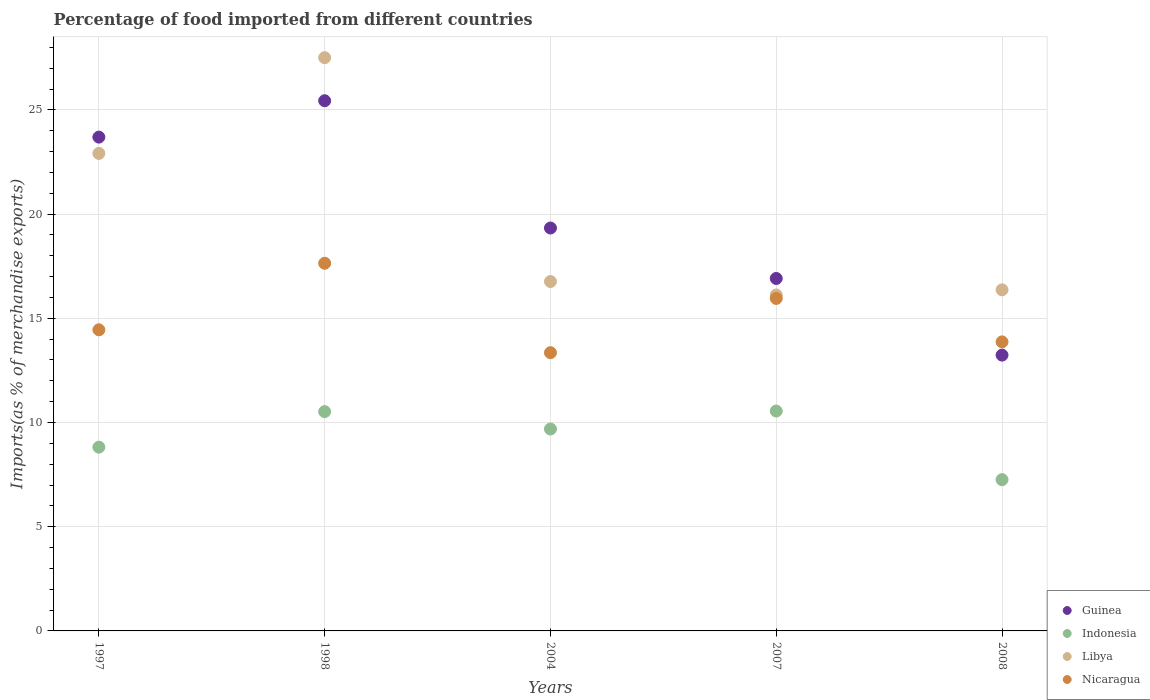How many different coloured dotlines are there?
Provide a succinct answer. 4. What is the percentage of imports to different countries in Libya in 2008?
Keep it short and to the point. 16.37. Across all years, what is the maximum percentage of imports to different countries in Indonesia?
Keep it short and to the point. 10.55. Across all years, what is the minimum percentage of imports to different countries in Guinea?
Give a very brief answer. 13.23. In which year was the percentage of imports to different countries in Guinea maximum?
Your response must be concise. 1998. What is the total percentage of imports to different countries in Libya in the graph?
Offer a terse response. 99.67. What is the difference between the percentage of imports to different countries in Nicaragua in 1997 and that in 2008?
Give a very brief answer. 0.58. What is the difference between the percentage of imports to different countries in Nicaragua in 1997 and the percentage of imports to different countries in Guinea in 2007?
Your answer should be very brief. -2.46. What is the average percentage of imports to different countries in Nicaragua per year?
Offer a terse response. 15.05. In the year 1997, what is the difference between the percentage of imports to different countries in Libya and percentage of imports to different countries in Indonesia?
Offer a terse response. 14.09. In how many years, is the percentage of imports to different countries in Indonesia greater than 22 %?
Keep it short and to the point. 0. What is the ratio of the percentage of imports to different countries in Guinea in 1997 to that in 2007?
Offer a terse response. 1.4. What is the difference between the highest and the second highest percentage of imports to different countries in Indonesia?
Offer a terse response. 0.03. What is the difference between the highest and the lowest percentage of imports to different countries in Guinea?
Offer a very short reply. 12.2. Is it the case that in every year, the sum of the percentage of imports to different countries in Nicaragua and percentage of imports to different countries in Libya  is greater than the percentage of imports to different countries in Guinea?
Ensure brevity in your answer.  Yes. Does the percentage of imports to different countries in Indonesia monotonically increase over the years?
Ensure brevity in your answer.  No. How many dotlines are there?
Keep it short and to the point. 4. How many years are there in the graph?
Provide a succinct answer. 5. What is the difference between two consecutive major ticks on the Y-axis?
Keep it short and to the point. 5. Does the graph contain any zero values?
Offer a very short reply. No. Does the graph contain grids?
Ensure brevity in your answer.  Yes. How many legend labels are there?
Your response must be concise. 4. How are the legend labels stacked?
Your answer should be compact. Vertical. What is the title of the graph?
Offer a terse response. Percentage of food imported from different countries. What is the label or title of the Y-axis?
Make the answer very short. Imports(as % of merchandise exports). What is the Imports(as % of merchandise exports) of Guinea in 1997?
Provide a succinct answer. 23.69. What is the Imports(as % of merchandise exports) of Indonesia in 1997?
Offer a terse response. 8.82. What is the Imports(as % of merchandise exports) in Libya in 1997?
Ensure brevity in your answer.  22.91. What is the Imports(as % of merchandise exports) of Nicaragua in 1997?
Provide a short and direct response. 14.45. What is the Imports(as % of merchandise exports) of Guinea in 1998?
Offer a terse response. 25.44. What is the Imports(as % of merchandise exports) in Indonesia in 1998?
Make the answer very short. 10.52. What is the Imports(as % of merchandise exports) of Libya in 1998?
Your answer should be very brief. 27.5. What is the Imports(as % of merchandise exports) in Nicaragua in 1998?
Make the answer very short. 17.64. What is the Imports(as % of merchandise exports) in Guinea in 2004?
Provide a succinct answer. 19.33. What is the Imports(as % of merchandise exports) in Indonesia in 2004?
Provide a succinct answer. 9.69. What is the Imports(as % of merchandise exports) of Libya in 2004?
Ensure brevity in your answer.  16.76. What is the Imports(as % of merchandise exports) of Nicaragua in 2004?
Offer a terse response. 13.35. What is the Imports(as % of merchandise exports) in Guinea in 2007?
Ensure brevity in your answer.  16.91. What is the Imports(as % of merchandise exports) of Indonesia in 2007?
Provide a succinct answer. 10.55. What is the Imports(as % of merchandise exports) in Libya in 2007?
Make the answer very short. 16.12. What is the Imports(as % of merchandise exports) of Nicaragua in 2007?
Your answer should be very brief. 15.95. What is the Imports(as % of merchandise exports) of Guinea in 2008?
Your answer should be compact. 13.23. What is the Imports(as % of merchandise exports) in Indonesia in 2008?
Keep it short and to the point. 7.26. What is the Imports(as % of merchandise exports) of Libya in 2008?
Give a very brief answer. 16.37. What is the Imports(as % of merchandise exports) in Nicaragua in 2008?
Provide a short and direct response. 13.87. Across all years, what is the maximum Imports(as % of merchandise exports) of Guinea?
Make the answer very short. 25.44. Across all years, what is the maximum Imports(as % of merchandise exports) in Indonesia?
Ensure brevity in your answer.  10.55. Across all years, what is the maximum Imports(as % of merchandise exports) of Libya?
Your response must be concise. 27.5. Across all years, what is the maximum Imports(as % of merchandise exports) of Nicaragua?
Give a very brief answer. 17.64. Across all years, what is the minimum Imports(as % of merchandise exports) in Guinea?
Offer a terse response. 13.23. Across all years, what is the minimum Imports(as % of merchandise exports) of Indonesia?
Your response must be concise. 7.26. Across all years, what is the minimum Imports(as % of merchandise exports) in Libya?
Make the answer very short. 16.12. Across all years, what is the minimum Imports(as % of merchandise exports) in Nicaragua?
Offer a terse response. 13.35. What is the total Imports(as % of merchandise exports) in Guinea in the graph?
Ensure brevity in your answer.  98.61. What is the total Imports(as % of merchandise exports) in Indonesia in the graph?
Offer a very short reply. 46.83. What is the total Imports(as % of merchandise exports) in Libya in the graph?
Provide a short and direct response. 99.67. What is the total Imports(as % of merchandise exports) in Nicaragua in the graph?
Provide a succinct answer. 75.26. What is the difference between the Imports(as % of merchandise exports) of Guinea in 1997 and that in 1998?
Offer a very short reply. -1.75. What is the difference between the Imports(as % of merchandise exports) of Indonesia in 1997 and that in 1998?
Offer a very short reply. -1.71. What is the difference between the Imports(as % of merchandise exports) of Libya in 1997 and that in 1998?
Give a very brief answer. -4.59. What is the difference between the Imports(as % of merchandise exports) of Nicaragua in 1997 and that in 1998?
Your answer should be compact. -3.19. What is the difference between the Imports(as % of merchandise exports) of Guinea in 1997 and that in 2004?
Your answer should be compact. 4.36. What is the difference between the Imports(as % of merchandise exports) of Indonesia in 1997 and that in 2004?
Offer a terse response. -0.87. What is the difference between the Imports(as % of merchandise exports) in Libya in 1997 and that in 2004?
Make the answer very short. 6.15. What is the difference between the Imports(as % of merchandise exports) of Nicaragua in 1997 and that in 2004?
Make the answer very short. 1.1. What is the difference between the Imports(as % of merchandise exports) of Guinea in 1997 and that in 2007?
Your answer should be very brief. 6.78. What is the difference between the Imports(as % of merchandise exports) in Indonesia in 1997 and that in 2007?
Provide a short and direct response. -1.73. What is the difference between the Imports(as % of merchandise exports) in Libya in 1997 and that in 2007?
Make the answer very short. 6.79. What is the difference between the Imports(as % of merchandise exports) in Nicaragua in 1997 and that in 2007?
Keep it short and to the point. -1.51. What is the difference between the Imports(as % of merchandise exports) in Guinea in 1997 and that in 2008?
Your answer should be very brief. 10.46. What is the difference between the Imports(as % of merchandise exports) of Indonesia in 1997 and that in 2008?
Offer a terse response. 1.56. What is the difference between the Imports(as % of merchandise exports) of Libya in 1997 and that in 2008?
Your answer should be very brief. 6.55. What is the difference between the Imports(as % of merchandise exports) of Nicaragua in 1997 and that in 2008?
Provide a short and direct response. 0.58. What is the difference between the Imports(as % of merchandise exports) of Guinea in 1998 and that in 2004?
Provide a succinct answer. 6.11. What is the difference between the Imports(as % of merchandise exports) of Indonesia in 1998 and that in 2004?
Your answer should be compact. 0.83. What is the difference between the Imports(as % of merchandise exports) of Libya in 1998 and that in 2004?
Offer a terse response. 10.74. What is the difference between the Imports(as % of merchandise exports) of Nicaragua in 1998 and that in 2004?
Offer a terse response. 4.29. What is the difference between the Imports(as % of merchandise exports) in Guinea in 1998 and that in 2007?
Your answer should be compact. 8.53. What is the difference between the Imports(as % of merchandise exports) of Indonesia in 1998 and that in 2007?
Provide a short and direct response. -0.03. What is the difference between the Imports(as % of merchandise exports) in Libya in 1998 and that in 2007?
Keep it short and to the point. 11.39. What is the difference between the Imports(as % of merchandise exports) in Nicaragua in 1998 and that in 2007?
Provide a succinct answer. 1.69. What is the difference between the Imports(as % of merchandise exports) in Guinea in 1998 and that in 2008?
Your answer should be compact. 12.2. What is the difference between the Imports(as % of merchandise exports) of Indonesia in 1998 and that in 2008?
Keep it short and to the point. 3.26. What is the difference between the Imports(as % of merchandise exports) in Libya in 1998 and that in 2008?
Offer a very short reply. 11.14. What is the difference between the Imports(as % of merchandise exports) in Nicaragua in 1998 and that in 2008?
Give a very brief answer. 3.77. What is the difference between the Imports(as % of merchandise exports) of Guinea in 2004 and that in 2007?
Give a very brief answer. 2.42. What is the difference between the Imports(as % of merchandise exports) of Indonesia in 2004 and that in 2007?
Give a very brief answer. -0.86. What is the difference between the Imports(as % of merchandise exports) in Libya in 2004 and that in 2007?
Make the answer very short. 0.65. What is the difference between the Imports(as % of merchandise exports) of Nicaragua in 2004 and that in 2007?
Offer a terse response. -2.6. What is the difference between the Imports(as % of merchandise exports) of Guinea in 2004 and that in 2008?
Your answer should be compact. 6.1. What is the difference between the Imports(as % of merchandise exports) of Indonesia in 2004 and that in 2008?
Keep it short and to the point. 2.43. What is the difference between the Imports(as % of merchandise exports) in Libya in 2004 and that in 2008?
Make the answer very short. 0.4. What is the difference between the Imports(as % of merchandise exports) of Nicaragua in 2004 and that in 2008?
Provide a succinct answer. -0.52. What is the difference between the Imports(as % of merchandise exports) in Guinea in 2007 and that in 2008?
Your answer should be very brief. 3.68. What is the difference between the Imports(as % of merchandise exports) of Indonesia in 2007 and that in 2008?
Keep it short and to the point. 3.29. What is the difference between the Imports(as % of merchandise exports) in Libya in 2007 and that in 2008?
Your response must be concise. -0.25. What is the difference between the Imports(as % of merchandise exports) of Nicaragua in 2007 and that in 2008?
Give a very brief answer. 2.09. What is the difference between the Imports(as % of merchandise exports) in Guinea in 1997 and the Imports(as % of merchandise exports) in Indonesia in 1998?
Give a very brief answer. 13.17. What is the difference between the Imports(as % of merchandise exports) in Guinea in 1997 and the Imports(as % of merchandise exports) in Libya in 1998?
Give a very brief answer. -3.81. What is the difference between the Imports(as % of merchandise exports) in Guinea in 1997 and the Imports(as % of merchandise exports) in Nicaragua in 1998?
Provide a succinct answer. 6.05. What is the difference between the Imports(as % of merchandise exports) of Indonesia in 1997 and the Imports(as % of merchandise exports) of Libya in 1998?
Offer a terse response. -18.69. What is the difference between the Imports(as % of merchandise exports) of Indonesia in 1997 and the Imports(as % of merchandise exports) of Nicaragua in 1998?
Provide a succinct answer. -8.82. What is the difference between the Imports(as % of merchandise exports) of Libya in 1997 and the Imports(as % of merchandise exports) of Nicaragua in 1998?
Provide a short and direct response. 5.27. What is the difference between the Imports(as % of merchandise exports) in Guinea in 1997 and the Imports(as % of merchandise exports) in Indonesia in 2004?
Your answer should be very brief. 14.01. What is the difference between the Imports(as % of merchandise exports) of Guinea in 1997 and the Imports(as % of merchandise exports) of Libya in 2004?
Provide a succinct answer. 6.93. What is the difference between the Imports(as % of merchandise exports) in Guinea in 1997 and the Imports(as % of merchandise exports) in Nicaragua in 2004?
Provide a short and direct response. 10.34. What is the difference between the Imports(as % of merchandise exports) in Indonesia in 1997 and the Imports(as % of merchandise exports) in Libya in 2004?
Your answer should be very brief. -7.95. What is the difference between the Imports(as % of merchandise exports) of Indonesia in 1997 and the Imports(as % of merchandise exports) of Nicaragua in 2004?
Your answer should be very brief. -4.53. What is the difference between the Imports(as % of merchandise exports) of Libya in 1997 and the Imports(as % of merchandise exports) of Nicaragua in 2004?
Make the answer very short. 9.56. What is the difference between the Imports(as % of merchandise exports) in Guinea in 1997 and the Imports(as % of merchandise exports) in Indonesia in 2007?
Keep it short and to the point. 13.14. What is the difference between the Imports(as % of merchandise exports) of Guinea in 1997 and the Imports(as % of merchandise exports) of Libya in 2007?
Your response must be concise. 7.57. What is the difference between the Imports(as % of merchandise exports) of Guinea in 1997 and the Imports(as % of merchandise exports) of Nicaragua in 2007?
Provide a succinct answer. 7.74. What is the difference between the Imports(as % of merchandise exports) in Indonesia in 1997 and the Imports(as % of merchandise exports) in Libya in 2007?
Keep it short and to the point. -7.3. What is the difference between the Imports(as % of merchandise exports) in Indonesia in 1997 and the Imports(as % of merchandise exports) in Nicaragua in 2007?
Make the answer very short. -7.14. What is the difference between the Imports(as % of merchandise exports) in Libya in 1997 and the Imports(as % of merchandise exports) in Nicaragua in 2007?
Offer a terse response. 6.96. What is the difference between the Imports(as % of merchandise exports) of Guinea in 1997 and the Imports(as % of merchandise exports) of Indonesia in 2008?
Your answer should be compact. 16.44. What is the difference between the Imports(as % of merchandise exports) in Guinea in 1997 and the Imports(as % of merchandise exports) in Libya in 2008?
Your answer should be compact. 7.33. What is the difference between the Imports(as % of merchandise exports) of Guinea in 1997 and the Imports(as % of merchandise exports) of Nicaragua in 2008?
Offer a very short reply. 9.82. What is the difference between the Imports(as % of merchandise exports) in Indonesia in 1997 and the Imports(as % of merchandise exports) in Libya in 2008?
Make the answer very short. -7.55. What is the difference between the Imports(as % of merchandise exports) in Indonesia in 1997 and the Imports(as % of merchandise exports) in Nicaragua in 2008?
Keep it short and to the point. -5.05. What is the difference between the Imports(as % of merchandise exports) in Libya in 1997 and the Imports(as % of merchandise exports) in Nicaragua in 2008?
Make the answer very short. 9.04. What is the difference between the Imports(as % of merchandise exports) in Guinea in 1998 and the Imports(as % of merchandise exports) in Indonesia in 2004?
Your answer should be compact. 15.75. What is the difference between the Imports(as % of merchandise exports) in Guinea in 1998 and the Imports(as % of merchandise exports) in Libya in 2004?
Your answer should be compact. 8.67. What is the difference between the Imports(as % of merchandise exports) in Guinea in 1998 and the Imports(as % of merchandise exports) in Nicaragua in 2004?
Make the answer very short. 12.09. What is the difference between the Imports(as % of merchandise exports) in Indonesia in 1998 and the Imports(as % of merchandise exports) in Libya in 2004?
Offer a very short reply. -6.24. What is the difference between the Imports(as % of merchandise exports) in Indonesia in 1998 and the Imports(as % of merchandise exports) in Nicaragua in 2004?
Provide a succinct answer. -2.83. What is the difference between the Imports(as % of merchandise exports) of Libya in 1998 and the Imports(as % of merchandise exports) of Nicaragua in 2004?
Your answer should be very brief. 14.15. What is the difference between the Imports(as % of merchandise exports) of Guinea in 1998 and the Imports(as % of merchandise exports) of Indonesia in 2007?
Your response must be concise. 14.89. What is the difference between the Imports(as % of merchandise exports) in Guinea in 1998 and the Imports(as % of merchandise exports) in Libya in 2007?
Keep it short and to the point. 9.32. What is the difference between the Imports(as % of merchandise exports) of Guinea in 1998 and the Imports(as % of merchandise exports) of Nicaragua in 2007?
Offer a very short reply. 9.48. What is the difference between the Imports(as % of merchandise exports) in Indonesia in 1998 and the Imports(as % of merchandise exports) in Libya in 2007?
Ensure brevity in your answer.  -5.6. What is the difference between the Imports(as % of merchandise exports) in Indonesia in 1998 and the Imports(as % of merchandise exports) in Nicaragua in 2007?
Give a very brief answer. -5.43. What is the difference between the Imports(as % of merchandise exports) in Libya in 1998 and the Imports(as % of merchandise exports) in Nicaragua in 2007?
Keep it short and to the point. 11.55. What is the difference between the Imports(as % of merchandise exports) of Guinea in 1998 and the Imports(as % of merchandise exports) of Indonesia in 2008?
Keep it short and to the point. 18.18. What is the difference between the Imports(as % of merchandise exports) in Guinea in 1998 and the Imports(as % of merchandise exports) in Libya in 2008?
Keep it short and to the point. 9.07. What is the difference between the Imports(as % of merchandise exports) in Guinea in 1998 and the Imports(as % of merchandise exports) in Nicaragua in 2008?
Your answer should be compact. 11.57. What is the difference between the Imports(as % of merchandise exports) of Indonesia in 1998 and the Imports(as % of merchandise exports) of Libya in 2008?
Provide a short and direct response. -5.84. What is the difference between the Imports(as % of merchandise exports) in Indonesia in 1998 and the Imports(as % of merchandise exports) in Nicaragua in 2008?
Make the answer very short. -3.35. What is the difference between the Imports(as % of merchandise exports) in Libya in 1998 and the Imports(as % of merchandise exports) in Nicaragua in 2008?
Ensure brevity in your answer.  13.64. What is the difference between the Imports(as % of merchandise exports) in Guinea in 2004 and the Imports(as % of merchandise exports) in Indonesia in 2007?
Ensure brevity in your answer.  8.78. What is the difference between the Imports(as % of merchandise exports) of Guinea in 2004 and the Imports(as % of merchandise exports) of Libya in 2007?
Ensure brevity in your answer.  3.21. What is the difference between the Imports(as % of merchandise exports) in Guinea in 2004 and the Imports(as % of merchandise exports) in Nicaragua in 2007?
Your answer should be compact. 3.38. What is the difference between the Imports(as % of merchandise exports) of Indonesia in 2004 and the Imports(as % of merchandise exports) of Libya in 2007?
Your response must be concise. -6.43. What is the difference between the Imports(as % of merchandise exports) in Indonesia in 2004 and the Imports(as % of merchandise exports) in Nicaragua in 2007?
Offer a terse response. -6.27. What is the difference between the Imports(as % of merchandise exports) in Libya in 2004 and the Imports(as % of merchandise exports) in Nicaragua in 2007?
Provide a short and direct response. 0.81. What is the difference between the Imports(as % of merchandise exports) in Guinea in 2004 and the Imports(as % of merchandise exports) in Indonesia in 2008?
Provide a succinct answer. 12.07. What is the difference between the Imports(as % of merchandise exports) in Guinea in 2004 and the Imports(as % of merchandise exports) in Libya in 2008?
Your response must be concise. 2.97. What is the difference between the Imports(as % of merchandise exports) of Guinea in 2004 and the Imports(as % of merchandise exports) of Nicaragua in 2008?
Your response must be concise. 5.46. What is the difference between the Imports(as % of merchandise exports) of Indonesia in 2004 and the Imports(as % of merchandise exports) of Libya in 2008?
Make the answer very short. -6.68. What is the difference between the Imports(as % of merchandise exports) of Indonesia in 2004 and the Imports(as % of merchandise exports) of Nicaragua in 2008?
Your answer should be very brief. -4.18. What is the difference between the Imports(as % of merchandise exports) in Libya in 2004 and the Imports(as % of merchandise exports) in Nicaragua in 2008?
Your response must be concise. 2.9. What is the difference between the Imports(as % of merchandise exports) of Guinea in 2007 and the Imports(as % of merchandise exports) of Indonesia in 2008?
Ensure brevity in your answer.  9.65. What is the difference between the Imports(as % of merchandise exports) in Guinea in 2007 and the Imports(as % of merchandise exports) in Libya in 2008?
Your response must be concise. 0.55. What is the difference between the Imports(as % of merchandise exports) in Guinea in 2007 and the Imports(as % of merchandise exports) in Nicaragua in 2008?
Offer a very short reply. 3.04. What is the difference between the Imports(as % of merchandise exports) of Indonesia in 2007 and the Imports(as % of merchandise exports) of Libya in 2008?
Your answer should be compact. -5.82. What is the difference between the Imports(as % of merchandise exports) of Indonesia in 2007 and the Imports(as % of merchandise exports) of Nicaragua in 2008?
Ensure brevity in your answer.  -3.32. What is the difference between the Imports(as % of merchandise exports) in Libya in 2007 and the Imports(as % of merchandise exports) in Nicaragua in 2008?
Your answer should be compact. 2.25. What is the average Imports(as % of merchandise exports) of Guinea per year?
Provide a succinct answer. 19.72. What is the average Imports(as % of merchandise exports) in Indonesia per year?
Make the answer very short. 9.37. What is the average Imports(as % of merchandise exports) of Libya per year?
Give a very brief answer. 19.93. What is the average Imports(as % of merchandise exports) in Nicaragua per year?
Ensure brevity in your answer.  15.05. In the year 1997, what is the difference between the Imports(as % of merchandise exports) in Guinea and Imports(as % of merchandise exports) in Indonesia?
Give a very brief answer. 14.88. In the year 1997, what is the difference between the Imports(as % of merchandise exports) in Guinea and Imports(as % of merchandise exports) in Libya?
Ensure brevity in your answer.  0.78. In the year 1997, what is the difference between the Imports(as % of merchandise exports) in Guinea and Imports(as % of merchandise exports) in Nicaragua?
Your answer should be compact. 9.25. In the year 1997, what is the difference between the Imports(as % of merchandise exports) of Indonesia and Imports(as % of merchandise exports) of Libya?
Provide a short and direct response. -14.09. In the year 1997, what is the difference between the Imports(as % of merchandise exports) in Indonesia and Imports(as % of merchandise exports) in Nicaragua?
Provide a succinct answer. -5.63. In the year 1997, what is the difference between the Imports(as % of merchandise exports) in Libya and Imports(as % of merchandise exports) in Nicaragua?
Your answer should be very brief. 8.46. In the year 1998, what is the difference between the Imports(as % of merchandise exports) in Guinea and Imports(as % of merchandise exports) in Indonesia?
Give a very brief answer. 14.92. In the year 1998, what is the difference between the Imports(as % of merchandise exports) in Guinea and Imports(as % of merchandise exports) in Libya?
Your answer should be very brief. -2.07. In the year 1998, what is the difference between the Imports(as % of merchandise exports) of Guinea and Imports(as % of merchandise exports) of Nicaragua?
Provide a succinct answer. 7.8. In the year 1998, what is the difference between the Imports(as % of merchandise exports) of Indonesia and Imports(as % of merchandise exports) of Libya?
Offer a very short reply. -16.98. In the year 1998, what is the difference between the Imports(as % of merchandise exports) in Indonesia and Imports(as % of merchandise exports) in Nicaragua?
Keep it short and to the point. -7.12. In the year 1998, what is the difference between the Imports(as % of merchandise exports) in Libya and Imports(as % of merchandise exports) in Nicaragua?
Give a very brief answer. 9.86. In the year 2004, what is the difference between the Imports(as % of merchandise exports) in Guinea and Imports(as % of merchandise exports) in Indonesia?
Give a very brief answer. 9.64. In the year 2004, what is the difference between the Imports(as % of merchandise exports) in Guinea and Imports(as % of merchandise exports) in Libya?
Keep it short and to the point. 2.57. In the year 2004, what is the difference between the Imports(as % of merchandise exports) of Guinea and Imports(as % of merchandise exports) of Nicaragua?
Your response must be concise. 5.98. In the year 2004, what is the difference between the Imports(as % of merchandise exports) of Indonesia and Imports(as % of merchandise exports) of Libya?
Make the answer very short. -7.08. In the year 2004, what is the difference between the Imports(as % of merchandise exports) in Indonesia and Imports(as % of merchandise exports) in Nicaragua?
Ensure brevity in your answer.  -3.66. In the year 2004, what is the difference between the Imports(as % of merchandise exports) in Libya and Imports(as % of merchandise exports) in Nicaragua?
Your response must be concise. 3.41. In the year 2007, what is the difference between the Imports(as % of merchandise exports) in Guinea and Imports(as % of merchandise exports) in Indonesia?
Make the answer very short. 6.36. In the year 2007, what is the difference between the Imports(as % of merchandise exports) in Guinea and Imports(as % of merchandise exports) in Libya?
Your response must be concise. 0.79. In the year 2007, what is the difference between the Imports(as % of merchandise exports) in Guinea and Imports(as % of merchandise exports) in Nicaragua?
Provide a succinct answer. 0.96. In the year 2007, what is the difference between the Imports(as % of merchandise exports) in Indonesia and Imports(as % of merchandise exports) in Libya?
Offer a terse response. -5.57. In the year 2007, what is the difference between the Imports(as % of merchandise exports) of Indonesia and Imports(as % of merchandise exports) of Nicaragua?
Your answer should be very brief. -5.4. In the year 2007, what is the difference between the Imports(as % of merchandise exports) of Libya and Imports(as % of merchandise exports) of Nicaragua?
Make the answer very short. 0.16. In the year 2008, what is the difference between the Imports(as % of merchandise exports) in Guinea and Imports(as % of merchandise exports) in Indonesia?
Offer a terse response. 5.98. In the year 2008, what is the difference between the Imports(as % of merchandise exports) in Guinea and Imports(as % of merchandise exports) in Libya?
Ensure brevity in your answer.  -3.13. In the year 2008, what is the difference between the Imports(as % of merchandise exports) in Guinea and Imports(as % of merchandise exports) in Nicaragua?
Your answer should be compact. -0.63. In the year 2008, what is the difference between the Imports(as % of merchandise exports) in Indonesia and Imports(as % of merchandise exports) in Libya?
Your response must be concise. -9.11. In the year 2008, what is the difference between the Imports(as % of merchandise exports) of Indonesia and Imports(as % of merchandise exports) of Nicaragua?
Make the answer very short. -6.61. In the year 2008, what is the difference between the Imports(as % of merchandise exports) of Libya and Imports(as % of merchandise exports) of Nicaragua?
Ensure brevity in your answer.  2.5. What is the ratio of the Imports(as % of merchandise exports) in Guinea in 1997 to that in 1998?
Your answer should be very brief. 0.93. What is the ratio of the Imports(as % of merchandise exports) of Indonesia in 1997 to that in 1998?
Provide a succinct answer. 0.84. What is the ratio of the Imports(as % of merchandise exports) in Libya in 1997 to that in 1998?
Your answer should be compact. 0.83. What is the ratio of the Imports(as % of merchandise exports) of Nicaragua in 1997 to that in 1998?
Your response must be concise. 0.82. What is the ratio of the Imports(as % of merchandise exports) in Guinea in 1997 to that in 2004?
Offer a very short reply. 1.23. What is the ratio of the Imports(as % of merchandise exports) of Indonesia in 1997 to that in 2004?
Keep it short and to the point. 0.91. What is the ratio of the Imports(as % of merchandise exports) of Libya in 1997 to that in 2004?
Give a very brief answer. 1.37. What is the ratio of the Imports(as % of merchandise exports) of Nicaragua in 1997 to that in 2004?
Provide a short and direct response. 1.08. What is the ratio of the Imports(as % of merchandise exports) of Guinea in 1997 to that in 2007?
Provide a short and direct response. 1.4. What is the ratio of the Imports(as % of merchandise exports) in Indonesia in 1997 to that in 2007?
Offer a very short reply. 0.84. What is the ratio of the Imports(as % of merchandise exports) of Libya in 1997 to that in 2007?
Your response must be concise. 1.42. What is the ratio of the Imports(as % of merchandise exports) in Nicaragua in 1997 to that in 2007?
Make the answer very short. 0.91. What is the ratio of the Imports(as % of merchandise exports) in Guinea in 1997 to that in 2008?
Your answer should be very brief. 1.79. What is the ratio of the Imports(as % of merchandise exports) of Indonesia in 1997 to that in 2008?
Your answer should be very brief. 1.21. What is the ratio of the Imports(as % of merchandise exports) in Libya in 1997 to that in 2008?
Offer a very short reply. 1.4. What is the ratio of the Imports(as % of merchandise exports) of Nicaragua in 1997 to that in 2008?
Your response must be concise. 1.04. What is the ratio of the Imports(as % of merchandise exports) in Guinea in 1998 to that in 2004?
Provide a short and direct response. 1.32. What is the ratio of the Imports(as % of merchandise exports) in Indonesia in 1998 to that in 2004?
Your answer should be compact. 1.09. What is the ratio of the Imports(as % of merchandise exports) in Libya in 1998 to that in 2004?
Provide a succinct answer. 1.64. What is the ratio of the Imports(as % of merchandise exports) of Nicaragua in 1998 to that in 2004?
Offer a terse response. 1.32. What is the ratio of the Imports(as % of merchandise exports) in Guinea in 1998 to that in 2007?
Ensure brevity in your answer.  1.5. What is the ratio of the Imports(as % of merchandise exports) in Indonesia in 1998 to that in 2007?
Your answer should be compact. 1. What is the ratio of the Imports(as % of merchandise exports) of Libya in 1998 to that in 2007?
Offer a terse response. 1.71. What is the ratio of the Imports(as % of merchandise exports) in Nicaragua in 1998 to that in 2007?
Provide a succinct answer. 1.11. What is the ratio of the Imports(as % of merchandise exports) in Guinea in 1998 to that in 2008?
Provide a succinct answer. 1.92. What is the ratio of the Imports(as % of merchandise exports) of Indonesia in 1998 to that in 2008?
Ensure brevity in your answer.  1.45. What is the ratio of the Imports(as % of merchandise exports) of Libya in 1998 to that in 2008?
Offer a terse response. 1.68. What is the ratio of the Imports(as % of merchandise exports) in Nicaragua in 1998 to that in 2008?
Provide a succinct answer. 1.27. What is the ratio of the Imports(as % of merchandise exports) of Guinea in 2004 to that in 2007?
Your answer should be compact. 1.14. What is the ratio of the Imports(as % of merchandise exports) in Indonesia in 2004 to that in 2007?
Your response must be concise. 0.92. What is the ratio of the Imports(as % of merchandise exports) of Libya in 2004 to that in 2007?
Your response must be concise. 1.04. What is the ratio of the Imports(as % of merchandise exports) in Nicaragua in 2004 to that in 2007?
Give a very brief answer. 0.84. What is the ratio of the Imports(as % of merchandise exports) of Guinea in 2004 to that in 2008?
Provide a succinct answer. 1.46. What is the ratio of the Imports(as % of merchandise exports) in Indonesia in 2004 to that in 2008?
Your answer should be very brief. 1.33. What is the ratio of the Imports(as % of merchandise exports) of Libya in 2004 to that in 2008?
Your answer should be compact. 1.02. What is the ratio of the Imports(as % of merchandise exports) in Nicaragua in 2004 to that in 2008?
Offer a terse response. 0.96. What is the ratio of the Imports(as % of merchandise exports) in Guinea in 2007 to that in 2008?
Your response must be concise. 1.28. What is the ratio of the Imports(as % of merchandise exports) in Indonesia in 2007 to that in 2008?
Your answer should be very brief. 1.45. What is the ratio of the Imports(as % of merchandise exports) in Libya in 2007 to that in 2008?
Your answer should be very brief. 0.98. What is the ratio of the Imports(as % of merchandise exports) of Nicaragua in 2007 to that in 2008?
Provide a succinct answer. 1.15. What is the difference between the highest and the second highest Imports(as % of merchandise exports) of Guinea?
Your answer should be compact. 1.75. What is the difference between the highest and the second highest Imports(as % of merchandise exports) of Indonesia?
Offer a terse response. 0.03. What is the difference between the highest and the second highest Imports(as % of merchandise exports) of Libya?
Ensure brevity in your answer.  4.59. What is the difference between the highest and the second highest Imports(as % of merchandise exports) of Nicaragua?
Give a very brief answer. 1.69. What is the difference between the highest and the lowest Imports(as % of merchandise exports) of Guinea?
Keep it short and to the point. 12.2. What is the difference between the highest and the lowest Imports(as % of merchandise exports) in Indonesia?
Ensure brevity in your answer.  3.29. What is the difference between the highest and the lowest Imports(as % of merchandise exports) in Libya?
Your answer should be very brief. 11.39. What is the difference between the highest and the lowest Imports(as % of merchandise exports) of Nicaragua?
Offer a very short reply. 4.29. 